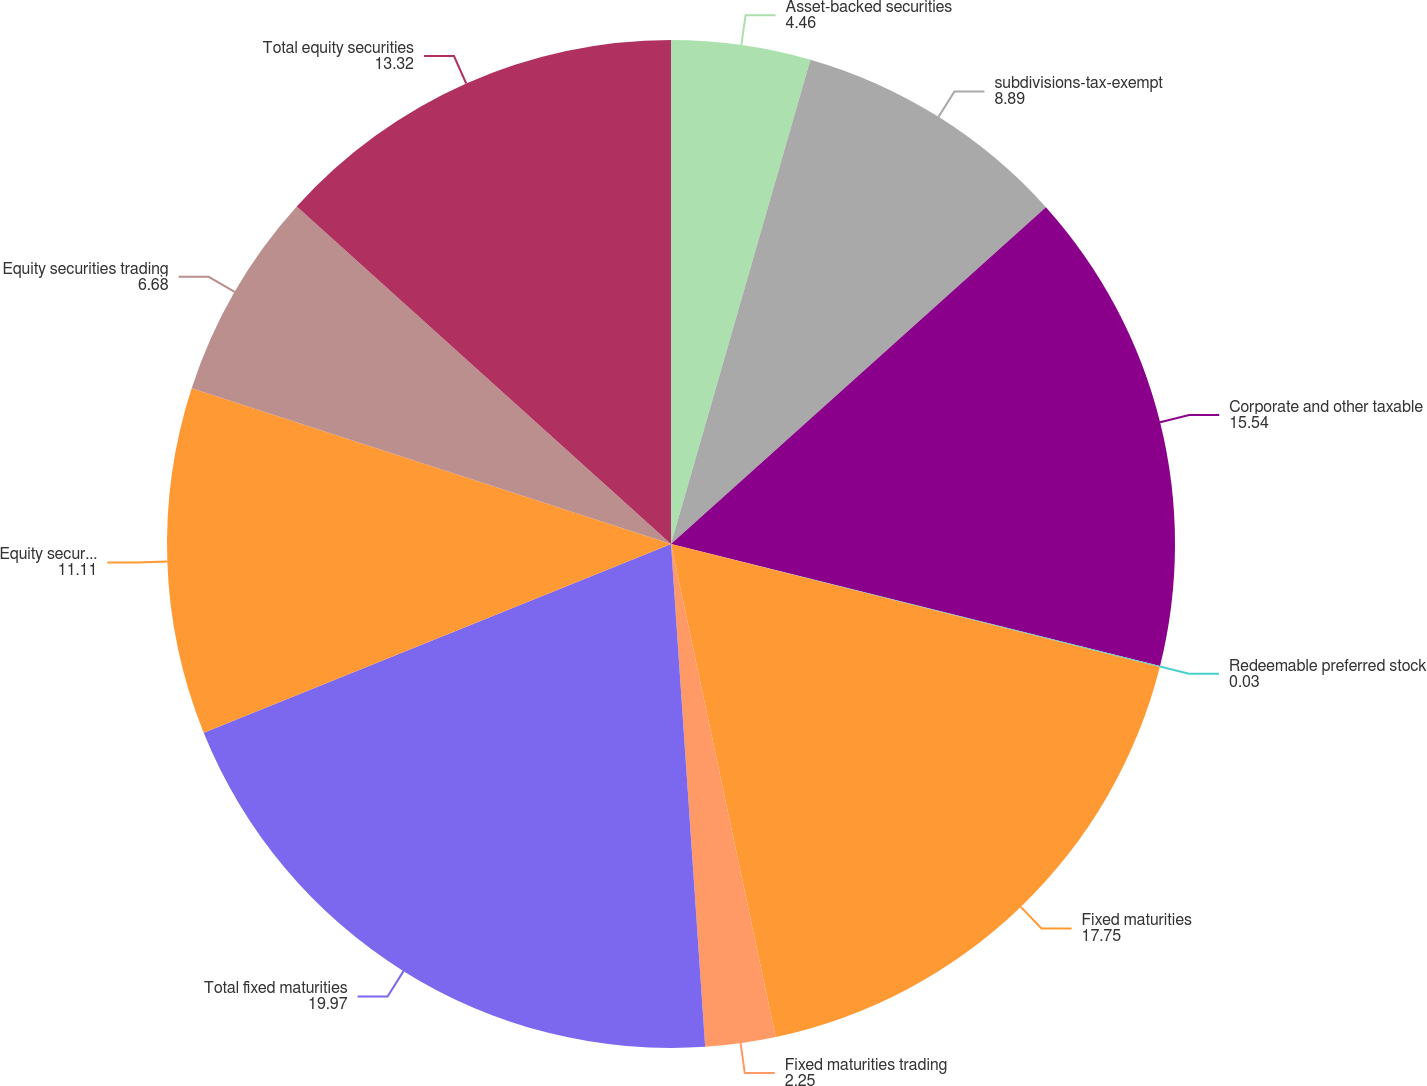Convert chart. <chart><loc_0><loc_0><loc_500><loc_500><pie_chart><fcel>Asset-backed securities<fcel>subdivisions-tax-exempt<fcel>Corporate and other taxable<fcel>Redeemable preferred stock<fcel>Fixed maturities<fcel>Fixed maturities trading<fcel>Total fixed maturities<fcel>Equity securities<fcel>Equity securities trading<fcel>Total equity securities<nl><fcel>4.46%<fcel>8.89%<fcel>15.54%<fcel>0.03%<fcel>17.75%<fcel>2.25%<fcel>19.97%<fcel>11.11%<fcel>6.68%<fcel>13.32%<nl></chart> 